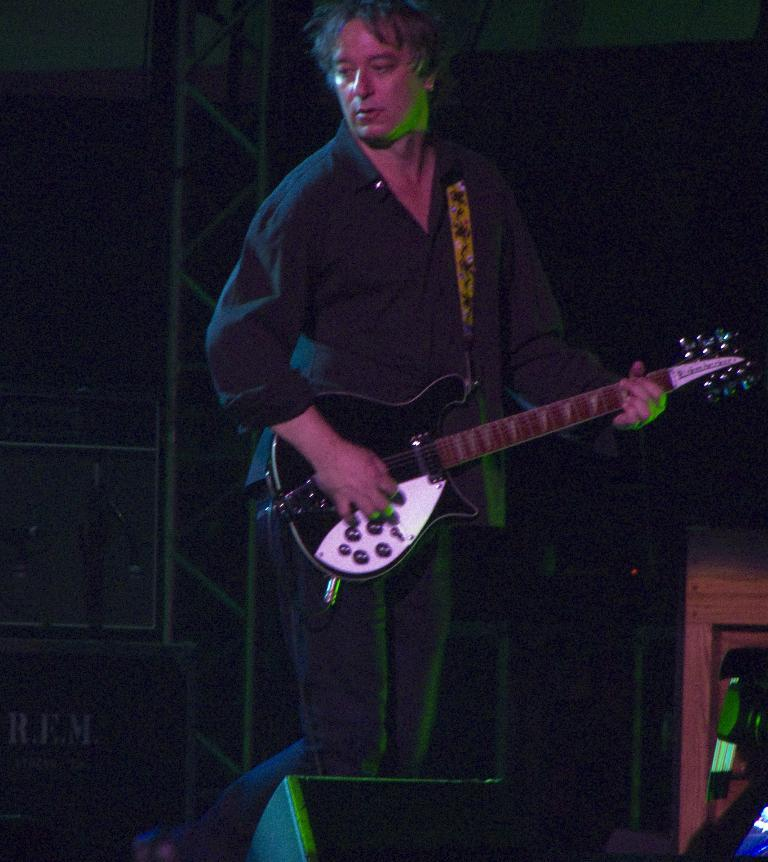What is the person in the image doing? The person is playing the guitar. What instrument is the person holding? The person is holding a guitar. What is in front of the person? There is a speaker in front of the person. What can be seen in the background? There is a stand in the background. Can you hear the person's voice in the image? There is no sound or audio in the image, so it is not possible to hear the person's voice. 